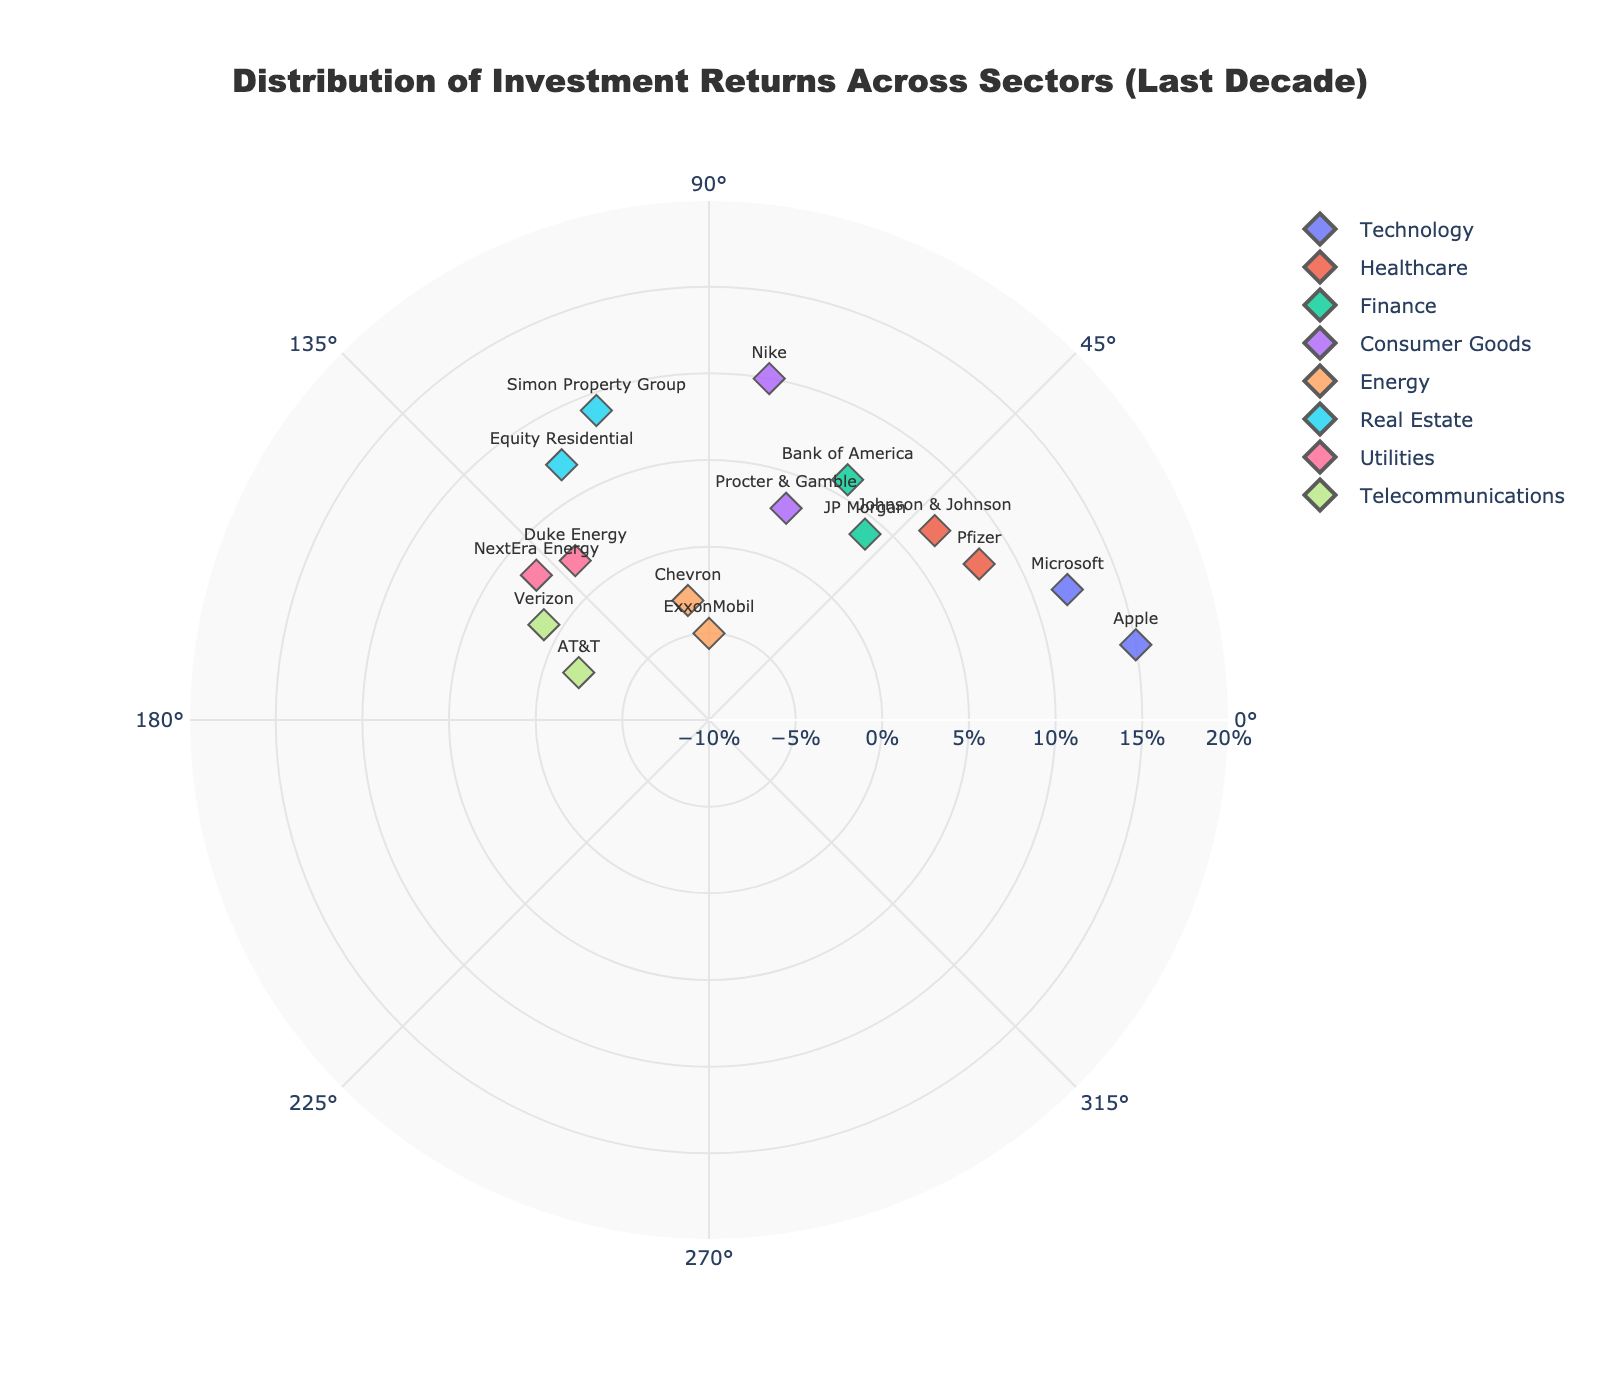what is the title of the figure? The title is usually positioned at the top center of the chart. Here it is written in bold and states the main idea of the visual represented, "Distribution of Investment Returns Across Sectors (Last Decade)".
Answer: Distribution of Investment Returns Across Sectors (Last Decade) Which sector has the highest investment return and what is the value? To find the highest investment return, look for the datapoint with the maximum radius. The company Apple has the highest return of 15%. They are in the Technology sector.
Answer: Technology, 15% Which sectors have negative investment returns and which companies are they? Look at the datapoints with negative radial values to determine which companies have negative investment returns, then check the associated sectors from the hover card or the text labels. The companies are ExxonMobil (-5%) and Chevron (-3%) from the Energy sector and AT&T (-2%) from the Telecommunications sector.
Answer: Energy and Telecommunications; ExxonMobil, Chevron, AT&T How many sectors have investment returns higher than 10%? Count the number of different sectors where there are datapoints with radial values greater than 10%. Only the Technology sector, with companies Apple (15%) and Microsoft (12%), has investment returns higher than 10%.
Answer: 1 What is the average investment return in the Healthcare sector? To find this, first, note the investment returns in the Healthcare sector: Pfizer (8%) and Johnson & Johnson (7%). Calculate the average by adding these values and dividing by 2: (8 + 7) / 2 = 7.5%.
Answer: 7.5% Which company in the Finance sector shows a higher return on investment? Compare the radial values (InvestmentReturns) of companies in the Finance sector, which are JP Morgan (4%) and Bank of America (6%). Bank of America shows a higher return.
Answer: Bank of America Are there more companies with positive or negative investment returns? Count the number of companies with positive radial values (greater than 0) and those with negative values (less than 0). There are 13 companies with positive returns and 3 with negative returns.
Answer: Positive Which sector has the most scattered return values and how can you tell? By observing the spread of radial values (distance from center) within each sector, identify which sector's points are most dispersed. The Technology sector has a large range (from Microsoft at 12% to Apple at 15%), indicating it's the most scattered.
Answer: Technology What is the combined investment return of the Consumer Goods sector? Add the radial values (InvestmentReturns) for the Consumer Goods sector: Procter & Gamble (3%) and Nike (10%): 3 + 10 = 13%.
Answer: 13% What is the median investment return value across all sectors? List out all the investment returns, then find the median by ordering these values and determining the middle value. Ordered returns: -5, -3, -2, 1, 2, 3, 3, 4, 6, 7, 7, 8, 9, 10, 12, 15. The middle values are 6 and 7, so the median is (6 + 7) / 2 = 6.5%.
Answer: 6.5% 